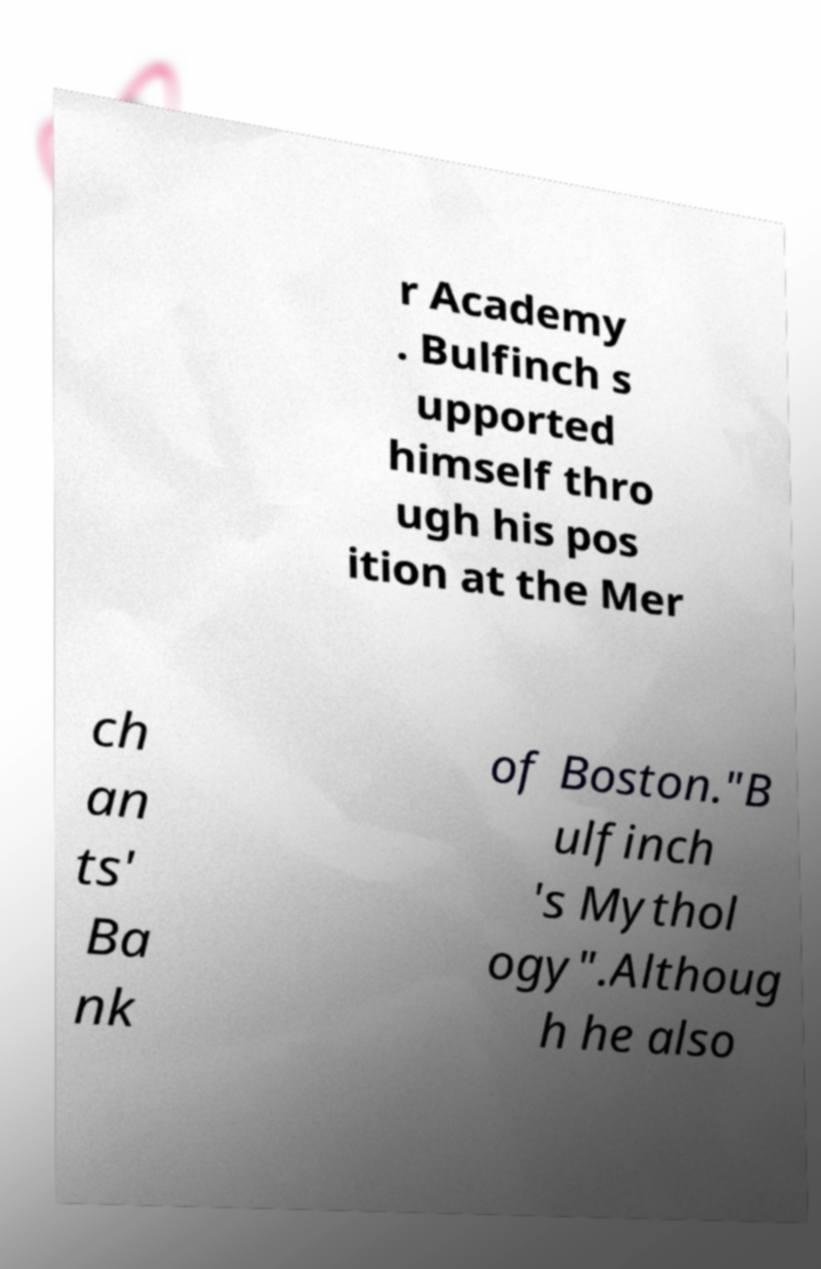I need the written content from this picture converted into text. Can you do that? r Academy . Bulfinch s upported himself thro ugh his pos ition at the Mer ch an ts' Ba nk of Boston."B ulfinch 's Mythol ogy".Althoug h he also 